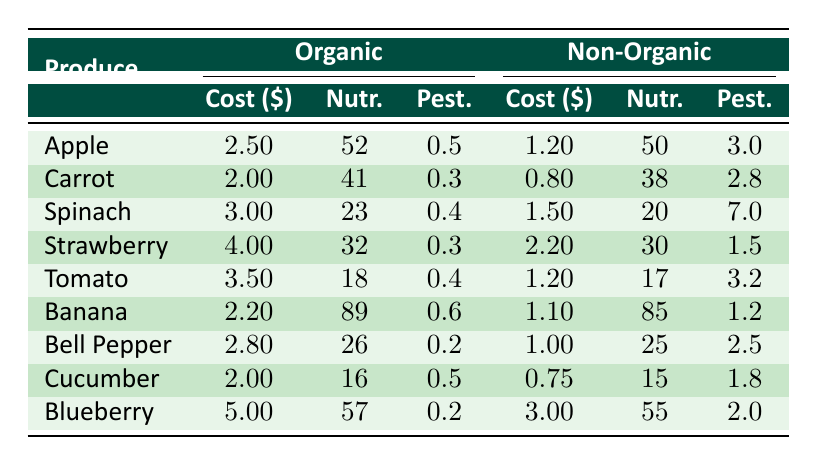What is the cost per pound of organic Spinach? The table indicates that the cost per pound of organic Spinach is listed under the "Organic" column for "Spinach." Referring to the table, it is 3.00.
Answer: 3.00 What is the nutritional value of non-organic Tomatoes? To find the nutritional value of non-organic Tomatoes, we look under the "Non-Organic" column specifically for "Tomato." The value is recorded as 17.
Answer: 17 Which produce has the highest pesticide residue among non-organic options? By scanning the "Pest." column under "Non-Organic," we see the values: 3.0 (Apple), 2.8 (Carrot), 7.0 (Spinach), 1.5 (Strawberry), 3.2 (Tomato), 1.2 (Banana), 2.5 (Bell Pepper), 1.8 (Cucumber), and 2.0 (Blueberry). The highest value is 7.0 for Spinach.
Answer: Spinach What is the average cost difference per pound between organic and non-organic Bell Peppers? The cost for organic Bell Peppers is 2.80, and for non-organic, it is 1.00. The difference is 2.80 - 1.00 = 1.80. To find the average, we only have one value to consider, so the average cost difference is 1.80.
Answer: 1.80 Is the nutritional value of organic Blueberries greater than that of non-organic Blueberries? The nutritional value for organic Blueberries is 57, while non-organic Blueberries have a value of 55. Comparing these values, yes, organic Blueberries have a higher nutritional value.
Answer: Yes Which produce item costs the least when comparing organic versions? By looking at the "Cost ($)" column under "Organic," the values are 2.50 (Apple), 2.00 (Carrot), 3.00 (Spinach), 4.00 (Strawberry), 3.50 (Tomato), 2.20 (Banana), 2.80 (Bell Pepper), 2.00 (Cucumber), and 5.00 (Blueberry). The least cost is 2.00 for both Carrot and Cucumber, making them the least expensive organic produce.
Answer: Carrot and Cucumber What is the total nutritional value of organic Apples and Bananas? The nutritional values for organic Apples and Bananas are 52 (Apple) and 89 (Banana), respectively. When adding these together, 52 + 89 = 141.
Answer: 141 Is the pesticide residue in non-organic Strawberries more than that in organic Strawberries? For non-organic Strawberries, the pesticide residue is 1.5, while for organic Strawberries, it is 0.3. Since 1.5 is greater than 0.3, the statement is true.
Answer: Yes 